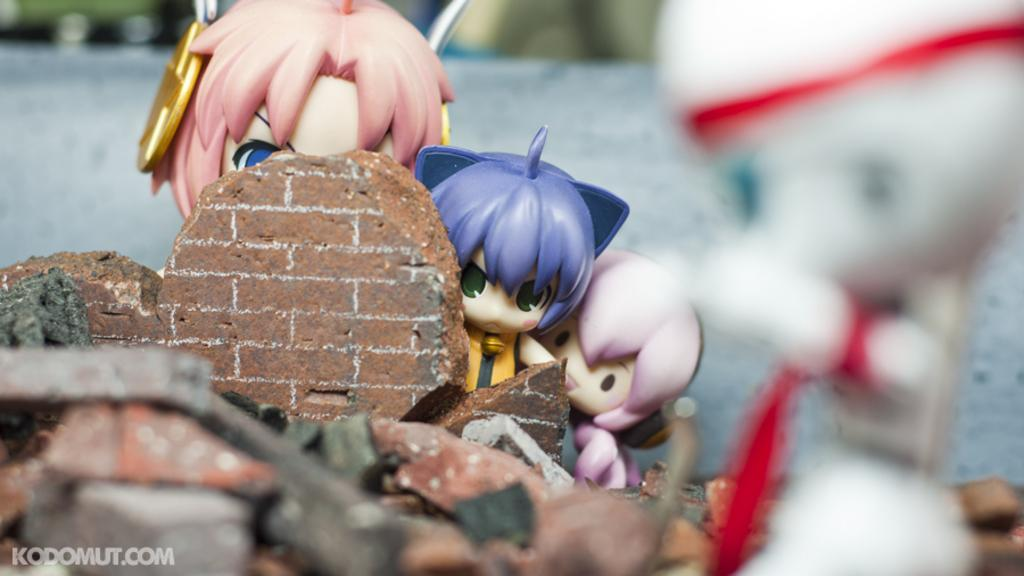What objects can be seen in the image? There are toys in the image. Where is the text located in the image? The text is at the bottom left hand corner of the image. What type of space-related expertise does the toy in the image possess? There is no indication of any space-related expertise or objects in the image; it simply features toys and text. 